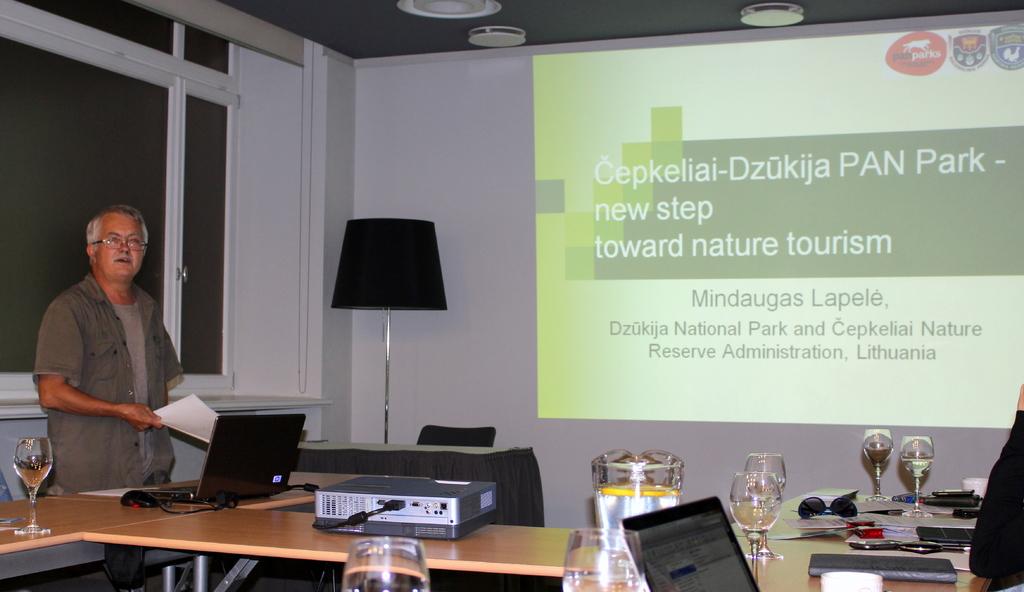What kind of tourism are they talking about?
Your answer should be very brief. Nature. 